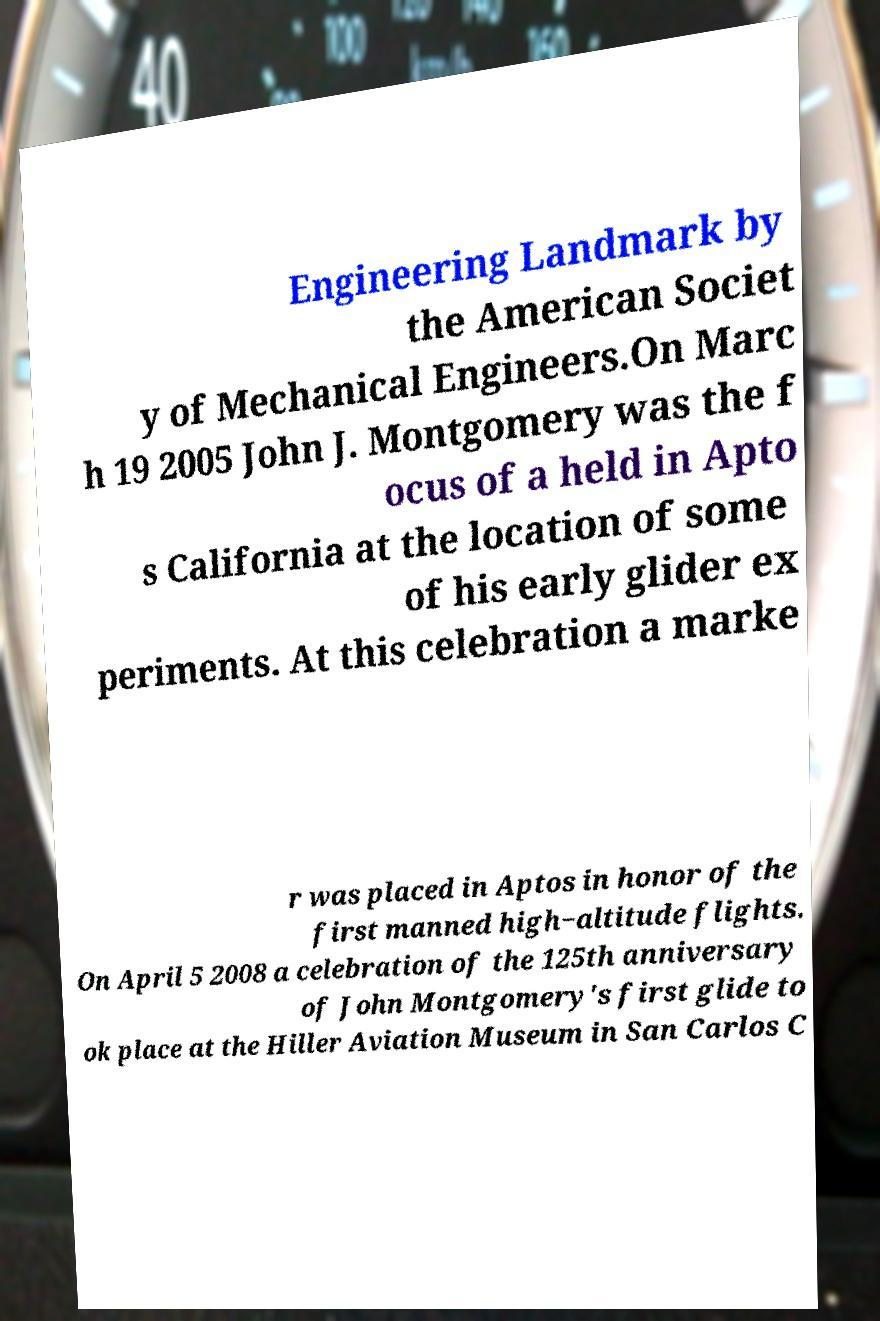There's text embedded in this image that I need extracted. Can you transcribe it verbatim? Engineering Landmark by the American Societ y of Mechanical Engineers.On Marc h 19 2005 John J. Montgomery was the f ocus of a held in Apto s California at the location of some of his early glider ex periments. At this celebration a marke r was placed in Aptos in honor of the first manned high−altitude flights. On April 5 2008 a celebration of the 125th anniversary of John Montgomery's first glide to ok place at the Hiller Aviation Museum in San Carlos C 